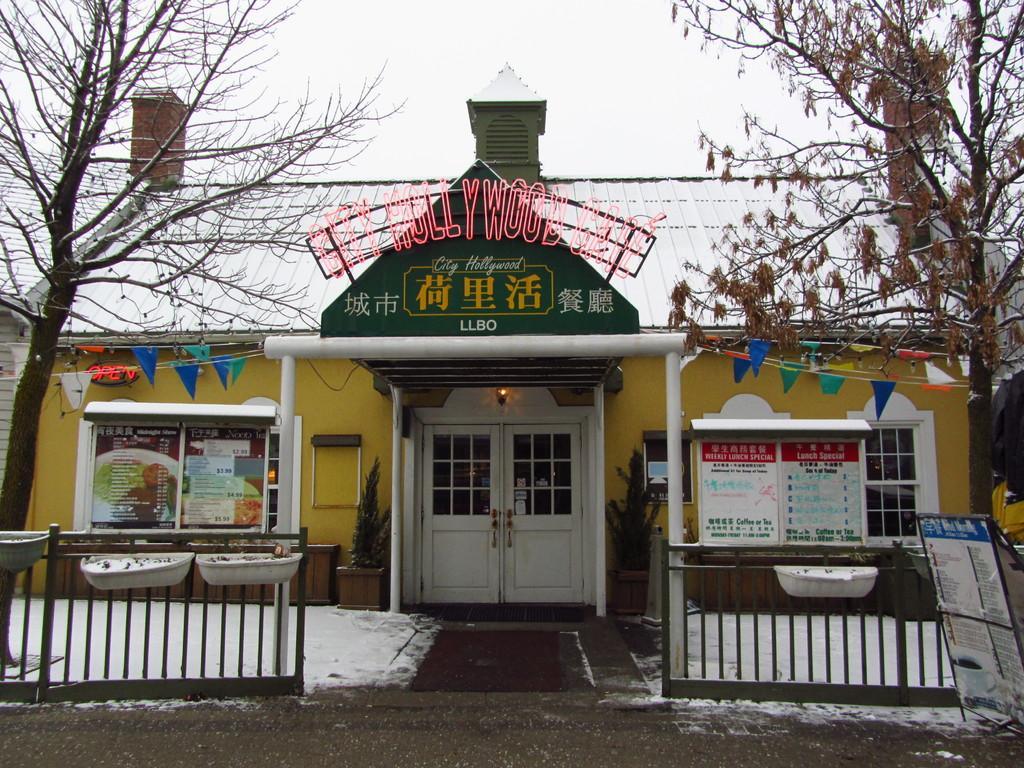Please provide a concise description of this image. Here we can see a house, door, boards, posters, flags, windows, plants, and fence. There are trees. In the background there is sky. 